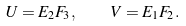<formula> <loc_0><loc_0><loc_500><loc_500>U = E _ { 2 } F _ { 3 } , \quad V = E _ { 1 } F _ { 2 } .</formula> 